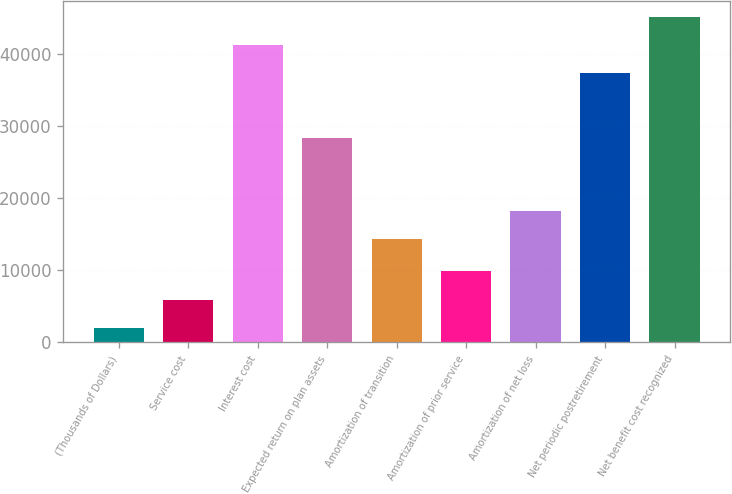Convert chart. <chart><loc_0><loc_0><loc_500><loc_500><bar_chart><fcel>(Thousands of Dollars)<fcel>Service cost<fcel>Interest cost<fcel>Expected return on plan assets<fcel>Amortization of transition<fcel>Amortization of prior service<fcel>Amortization of net loss<fcel>Net periodic postretirement<fcel>Net benefit cost recognized<nl><fcel>2012<fcel>5932.8<fcel>41249.8<fcel>28409<fcel>14320<fcel>9853.6<fcel>18240.8<fcel>37329<fcel>45170.6<nl></chart> 